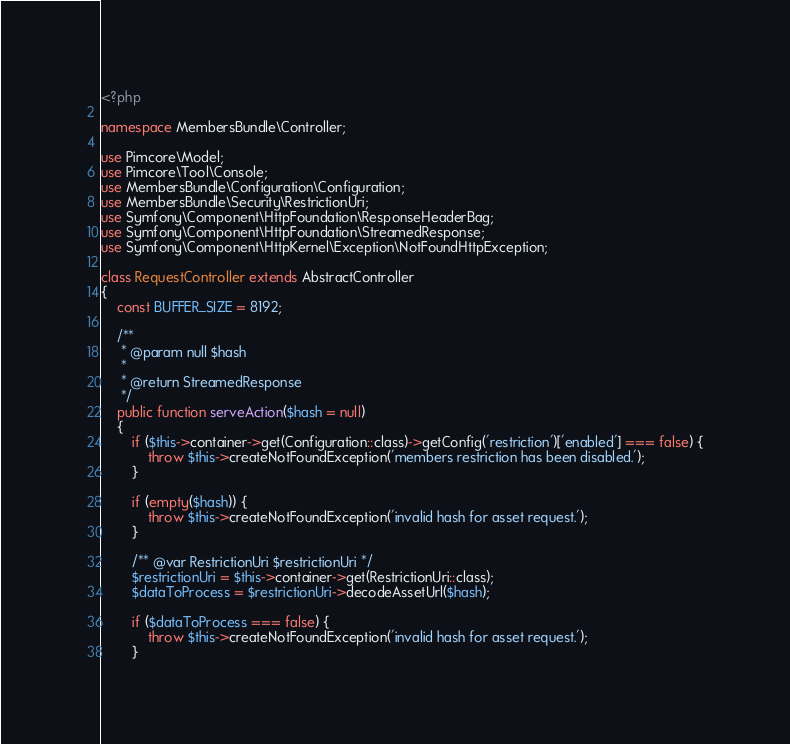<code> <loc_0><loc_0><loc_500><loc_500><_PHP_><?php

namespace MembersBundle\Controller;

use Pimcore\Model;
use Pimcore\Tool\Console;
use MembersBundle\Configuration\Configuration;
use MembersBundle\Security\RestrictionUri;
use Symfony\Component\HttpFoundation\ResponseHeaderBag;
use Symfony\Component\HttpFoundation\StreamedResponse;
use Symfony\Component\HttpKernel\Exception\NotFoundHttpException;

class RequestController extends AbstractController
{
    const BUFFER_SIZE = 8192;

    /**
     * @param null $hash
     *
     * @return StreamedResponse
     */
    public function serveAction($hash = null)
    {
        if ($this->container->get(Configuration::class)->getConfig('restriction')['enabled'] === false) {
            throw $this->createNotFoundException('members restriction has been disabled.');
        }

        if (empty($hash)) {
            throw $this->createNotFoundException('invalid hash for asset request.');
        }

        /** @var RestrictionUri $restrictionUri */
        $restrictionUri = $this->container->get(RestrictionUri::class);
        $dataToProcess = $restrictionUri->decodeAssetUrl($hash);

        if ($dataToProcess === false) {
            throw $this->createNotFoundException('invalid hash for asset request.');
        }
</code> 